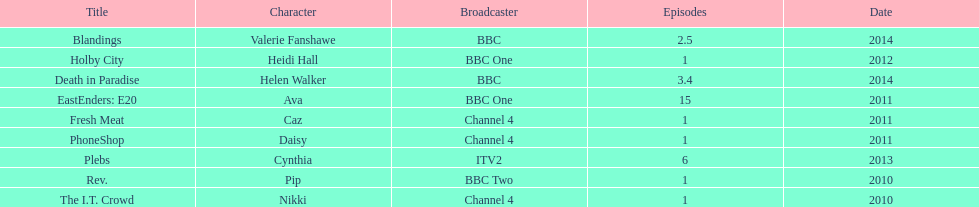Which broadcaster hosted 3 titles but they had only 1 episode? Channel 4. 